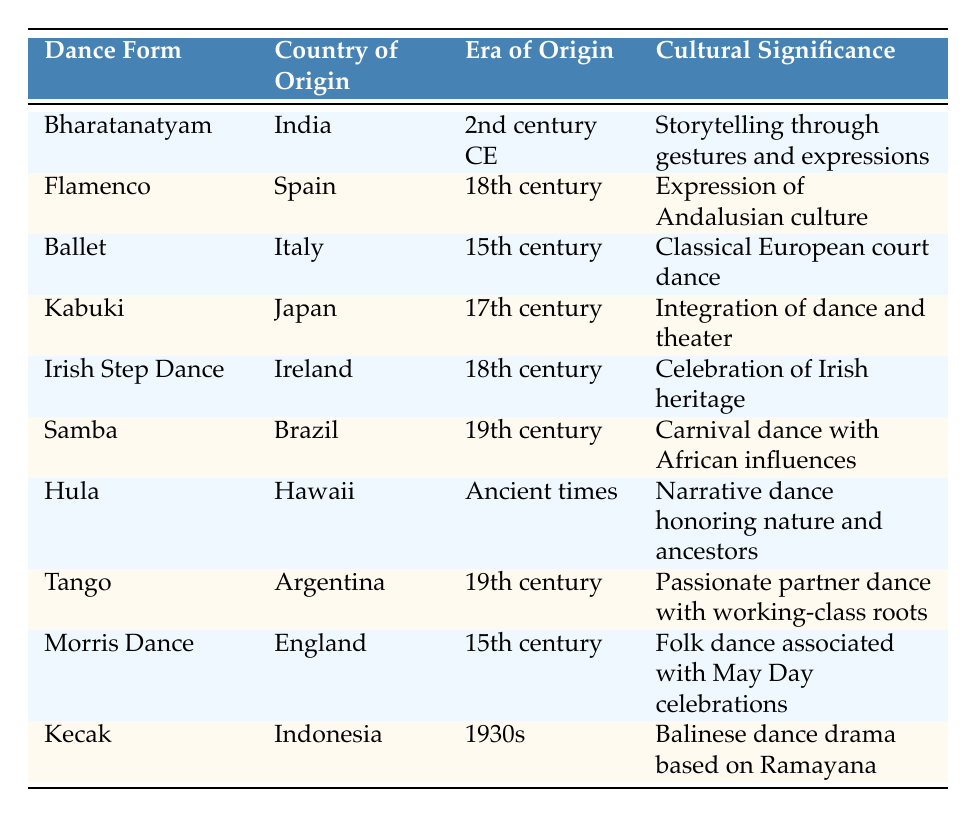What is the country of origin for Flamenco? From the table, we can easily locate the row for Flamenco. It is listed under the "Country of Origin" column, which states that Flamenco originates from Spain.
Answer: Spain Which dance form originated in the 19th century? In the table, we look for the rows that specify the "Era of Origin" as the 19th century. We find two dance forms: Samba and Tango.
Answer: Samba, Tango Is Bharatanatyam associated with storytelling? The cultural significance of Bharatanatyam is found in its description, which mentions "Storytelling through gestures and expressions." Therefore, the answer is yes.
Answer: Yes How many dance forms have a cultural significance related to heritage? We examine the cultural significance of each dance form in the table. The dance forms with significance related to heritage are Irish Step Dance and Tango. Hence, there are two such forms.
Answer: 2 Which dance form has its origins in ancient times? By scanning the "Era of Origin" column, we find that Hula is the only dance form designated as having origins in "Ancient times."
Answer: Hula Is Kabuki a form of dance that integrates theater? The description of Kabuki in the cultural significance column states that it is an "Integration of dance and theater." Therefore, the answer is yes.
Answer: Yes What is the cultural significance of Morris Dance? Referring to the Morris Dance row in the cultural significance column, it states that the dance is "associated with May Day celebrations." Thus, this could be considered its cultural significance.
Answer: Associated with May Day celebrations Which of the dance forms listed has origins from Japan? Looking through the table, we find that Kabuki is the only dance form with its origin listed as Japan.
Answer: Kabuki What is the difference between the earliest and latest eras of origin in the table? The earliest era of origin is "Ancient times" (associated with Hula), and the latest is "1930s" (associated with Kecak). To state this as a difference in years, we recognize that there is no numeric value for "Ancient times" but it is certainly before the 1930s. Thus, the earliest and latest cannot be precisely quantified in a mathematical sense but indicate a wide time gap.
Answer: Cannot be precisely quantified 